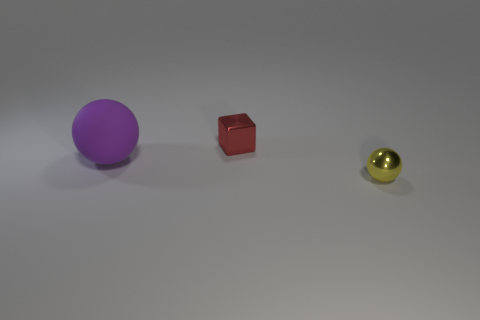Add 1 shiny objects. How many objects exist? 4 Subtract all spheres. How many objects are left? 1 Subtract all tiny metallic blocks. Subtract all large blue matte cylinders. How many objects are left? 2 Add 1 large matte spheres. How many large matte spheres are left? 2 Add 1 small cubes. How many small cubes exist? 2 Subtract 0 brown cylinders. How many objects are left? 3 